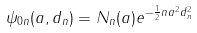Convert formula to latex. <formula><loc_0><loc_0><loc_500><loc_500>\psi _ { 0 n } ( a , d _ { n } ) = N _ { n } ( a ) e ^ { - \frac { 1 } { 2 } n a ^ { 2 } d _ { n } ^ { 2 } }</formula> 